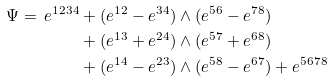Convert formula to latex. <formula><loc_0><loc_0><loc_500><loc_500>\Psi = \, e ^ { 1 2 3 4 } & + ( e ^ { 1 2 } - e ^ { 3 4 } ) \wedge ( e ^ { 5 6 } - e ^ { 7 8 } ) \\ & + ( e ^ { 1 3 } + e ^ { 2 4 } ) \wedge ( e ^ { 5 7 } + e ^ { 6 8 } ) \\ & + ( e ^ { 1 4 } - e ^ { 2 3 } ) \wedge ( e ^ { 5 8 } - e ^ { 6 7 } ) + e ^ { 5 6 7 8 } \\</formula> 